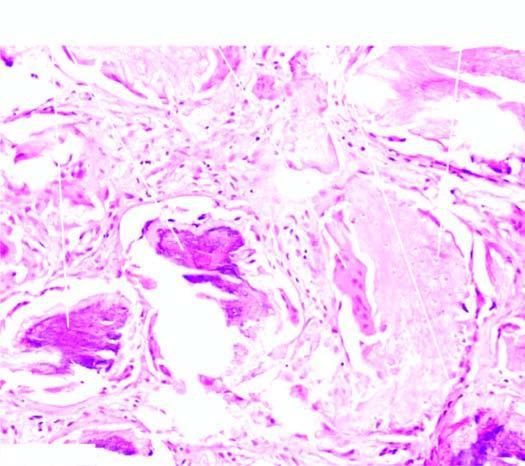does the tumour show islands and lobules within the dermis which are composed of two types of cells: outer basophilic cells and inner shadow cells?
Answer the question using a single word or phrase. Yes 